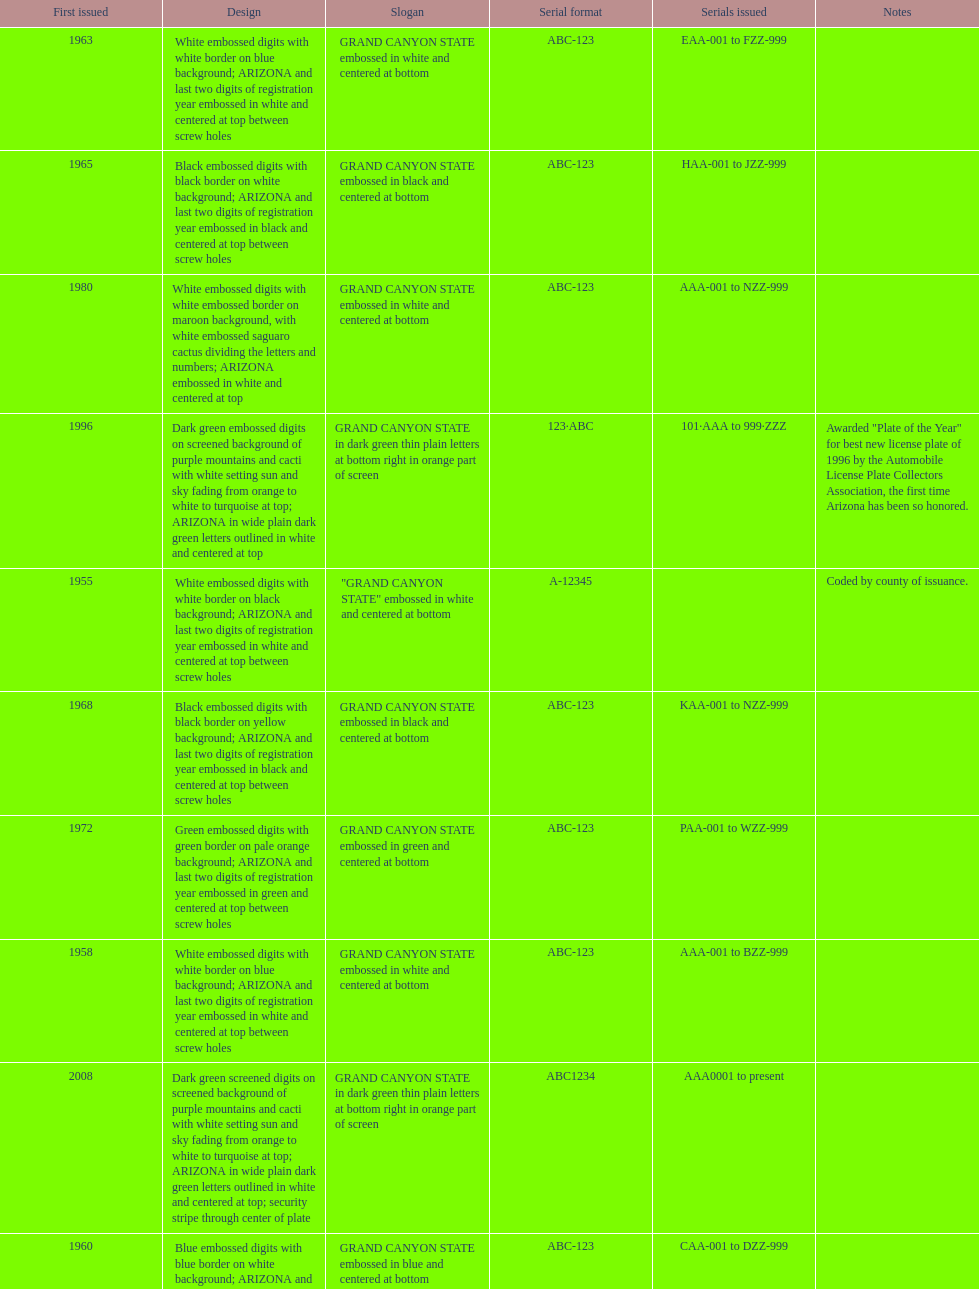What is the standard serial arrangement of the arizona license plates? ABC-123. Would you mind parsing the complete table? {'header': ['First issued', 'Design', 'Slogan', 'Serial format', 'Serials issued', 'Notes'], 'rows': [['1963', 'White embossed digits with white border on blue background; ARIZONA and last two digits of registration year embossed in white and centered at top between screw holes', 'GRAND CANYON STATE embossed in white and centered at bottom', 'ABC-123', 'EAA-001 to FZZ-999', ''], ['1965', 'Black embossed digits with black border on white background; ARIZONA and last two digits of registration year embossed in black and centered at top between screw holes', 'GRAND CANYON STATE embossed in black and centered at bottom', 'ABC-123', 'HAA-001 to JZZ-999', ''], ['1980', 'White embossed digits with white embossed border on maroon background, with white embossed saguaro cactus dividing the letters and numbers; ARIZONA embossed in white and centered at top', 'GRAND CANYON STATE embossed in white and centered at bottom', 'ABC-123', 'AAA-001 to NZZ-999', ''], ['1996', 'Dark green embossed digits on screened background of purple mountains and cacti with white setting sun and sky fading from orange to white to turquoise at top; ARIZONA in wide plain dark green letters outlined in white and centered at top', 'GRAND CANYON STATE in dark green thin plain letters at bottom right in orange part of screen', '123·ABC', '101·AAA to 999·ZZZ', 'Awarded "Plate of the Year" for best new license plate of 1996 by the Automobile License Plate Collectors Association, the first time Arizona has been so honored.'], ['1955', 'White embossed digits with white border on black background; ARIZONA and last two digits of registration year embossed in white and centered at top between screw holes', '"GRAND CANYON STATE" embossed in white and centered at bottom', 'A-12345', '', 'Coded by county of issuance.'], ['1968', 'Black embossed digits with black border on yellow background; ARIZONA and last two digits of registration year embossed in black and centered at top between screw holes', 'GRAND CANYON STATE embossed in black and centered at bottom', 'ABC-123', 'KAA-001 to NZZ-999', ''], ['1972', 'Green embossed digits with green border on pale orange background; ARIZONA and last two digits of registration year embossed in green and centered at top between screw holes', 'GRAND CANYON STATE embossed in green and centered at bottom', 'ABC-123', 'PAA-001 to WZZ-999', ''], ['1958', 'White embossed digits with white border on blue background; ARIZONA and last two digits of registration year embossed in white and centered at top between screw holes', 'GRAND CANYON STATE embossed in white and centered at bottom', 'ABC-123', 'AAA-001 to BZZ-999', ''], ['2008', 'Dark green screened digits on screened background of purple mountains and cacti with white setting sun and sky fading from orange to white to turquoise at top; ARIZONA in wide plain dark green letters outlined in white and centered at top; security stripe through center of plate', 'GRAND CANYON STATE in dark green thin plain letters at bottom right in orange part of screen', 'ABC1234', 'AAA0001 to present', ''], ['1960', 'Blue embossed digits with blue border on white background; ARIZONA and last two digits of registration year embossed in blue and centered at top between screw holes', 'GRAND CANYON STATE embossed in blue and centered at bottom', 'ABC-123', 'CAA-001 to DZZ-999', '']]} 